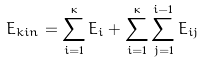Convert formula to latex. <formula><loc_0><loc_0><loc_500><loc_500>E _ { k i n } = \sum _ { i = 1 } ^ { \kappa } E _ { i } + \sum _ { i = 1 } ^ { \kappa } \sum _ { j = 1 } ^ { i - 1 } E _ { i j }</formula> 